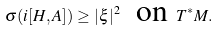Convert formula to latex. <formula><loc_0><loc_0><loc_500><loc_500>\sigma ( i [ H , A ] ) \geq | \xi | ^ { 2 } \ \text { on } T ^ { * } M .</formula> 